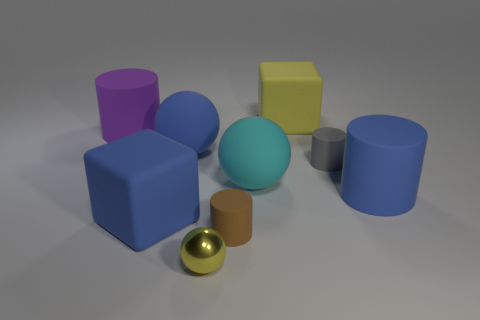Is there anything else that has the same material as the yellow sphere?
Ensure brevity in your answer.  No. There is a cube in front of the big purple rubber thing; what size is it?
Ensure brevity in your answer.  Large. Are there any big rubber objects of the same color as the small sphere?
Provide a short and direct response. Yes. Is the size of the block that is to the left of the brown rubber cylinder the same as the big blue rubber cylinder?
Your response must be concise. Yes. The small shiny sphere is what color?
Keep it short and to the point. Yellow. What color is the tiny cylinder that is left of the big rubber object that is behind the large purple object?
Your answer should be compact. Brown. Is there a red ball made of the same material as the cyan ball?
Ensure brevity in your answer.  No. What is the purple thing left of the blue rubber object that is right of the large yellow matte thing made of?
Keep it short and to the point. Rubber. How many purple objects have the same shape as the brown object?
Give a very brief answer. 1. What is the shape of the large cyan rubber object?
Ensure brevity in your answer.  Sphere. 